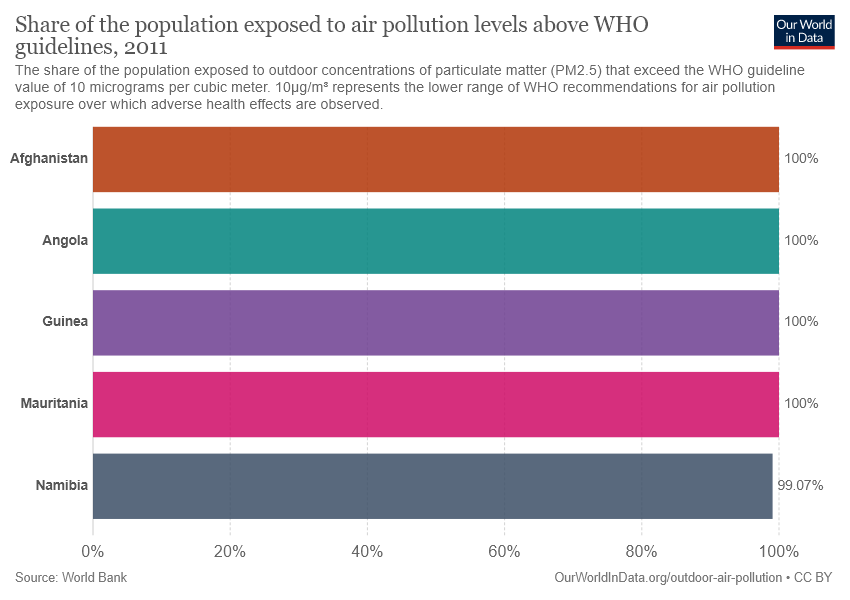Point out several critical features in this image. The middle bar in the chart has a purple color. According to the data, at least 100% of the bars had air pollution levels that were above acceptable levels. 